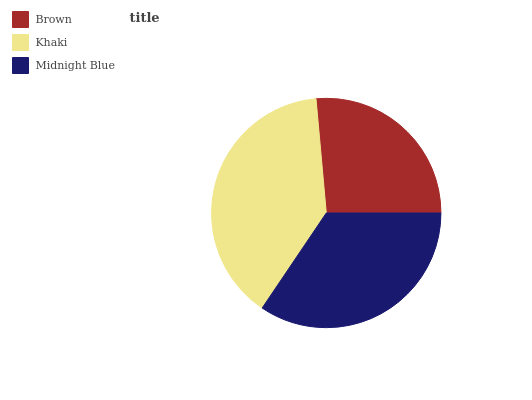Is Brown the minimum?
Answer yes or no. Yes. Is Khaki the maximum?
Answer yes or no. Yes. Is Midnight Blue the minimum?
Answer yes or no. No. Is Midnight Blue the maximum?
Answer yes or no. No. Is Khaki greater than Midnight Blue?
Answer yes or no. Yes. Is Midnight Blue less than Khaki?
Answer yes or no. Yes. Is Midnight Blue greater than Khaki?
Answer yes or no. No. Is Khaki less than Midnight Blue?
Answer yes or no. No. Is Midnight Blue the high median?
Answer yes or no. Yes. Is Midnight Blue the low median?
Answer yes or no. Yes. Is Khaki the high median?
Answer yes or no. No. Is Khaki the low median?
Answer yes or no. No. 